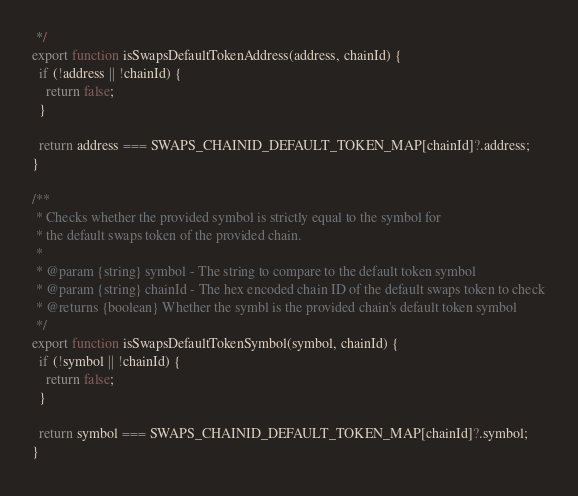Convert code to text. <code><loc_0><loc_0><loc_500><loc_500><_JavaScript_> */
export function isSwapsDefaultTokenAddress(address, chainId) {
  if (!address || !chainId) {
    return false;
  }

  return address === SWAPS_CHAINID_DEFAULT_TOKEN_MAP[chainId]?.address;
}

/**
 * Checks whether the provided symbol is strictly equal to the symbol for
 * the default swaps token of the provided chain.
 *
 * @param {string} symbol - The string to compare to the default token symbol
 * @param {string} chainId - The hex encoded chain ID of the default swaps token to check
 * @returns {boolean} Whether the symbl is the provided chain's default token symbol
 */
export function isSwapsDefaultTokenSymbol(symbol, chainId) {
  if (!symbol || !chainId) {
    return false;
  }

  return symbol === SWAPS_CHAINID_DEFAULT_TOKEN_MAP[chainId]?.symbol;
}
</code> 